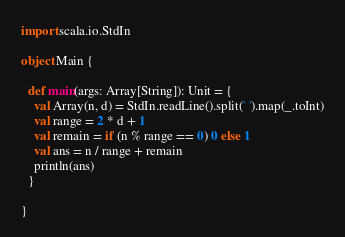<code> <loc_0><loc_0><loc_500><loc_500><_Scala_>import scala.io.StdIn

object Main {

  def main(args: Array[String]): Unit = {
    val Array(n, d) = StdIn.readLine().split(' ').map(_.toInt)
    val range = 2 * d + 1
    val remain = if (n % range == 0) 0 else 1
    val ans = n / range + remain
    println(ans)
  }

}</code> 